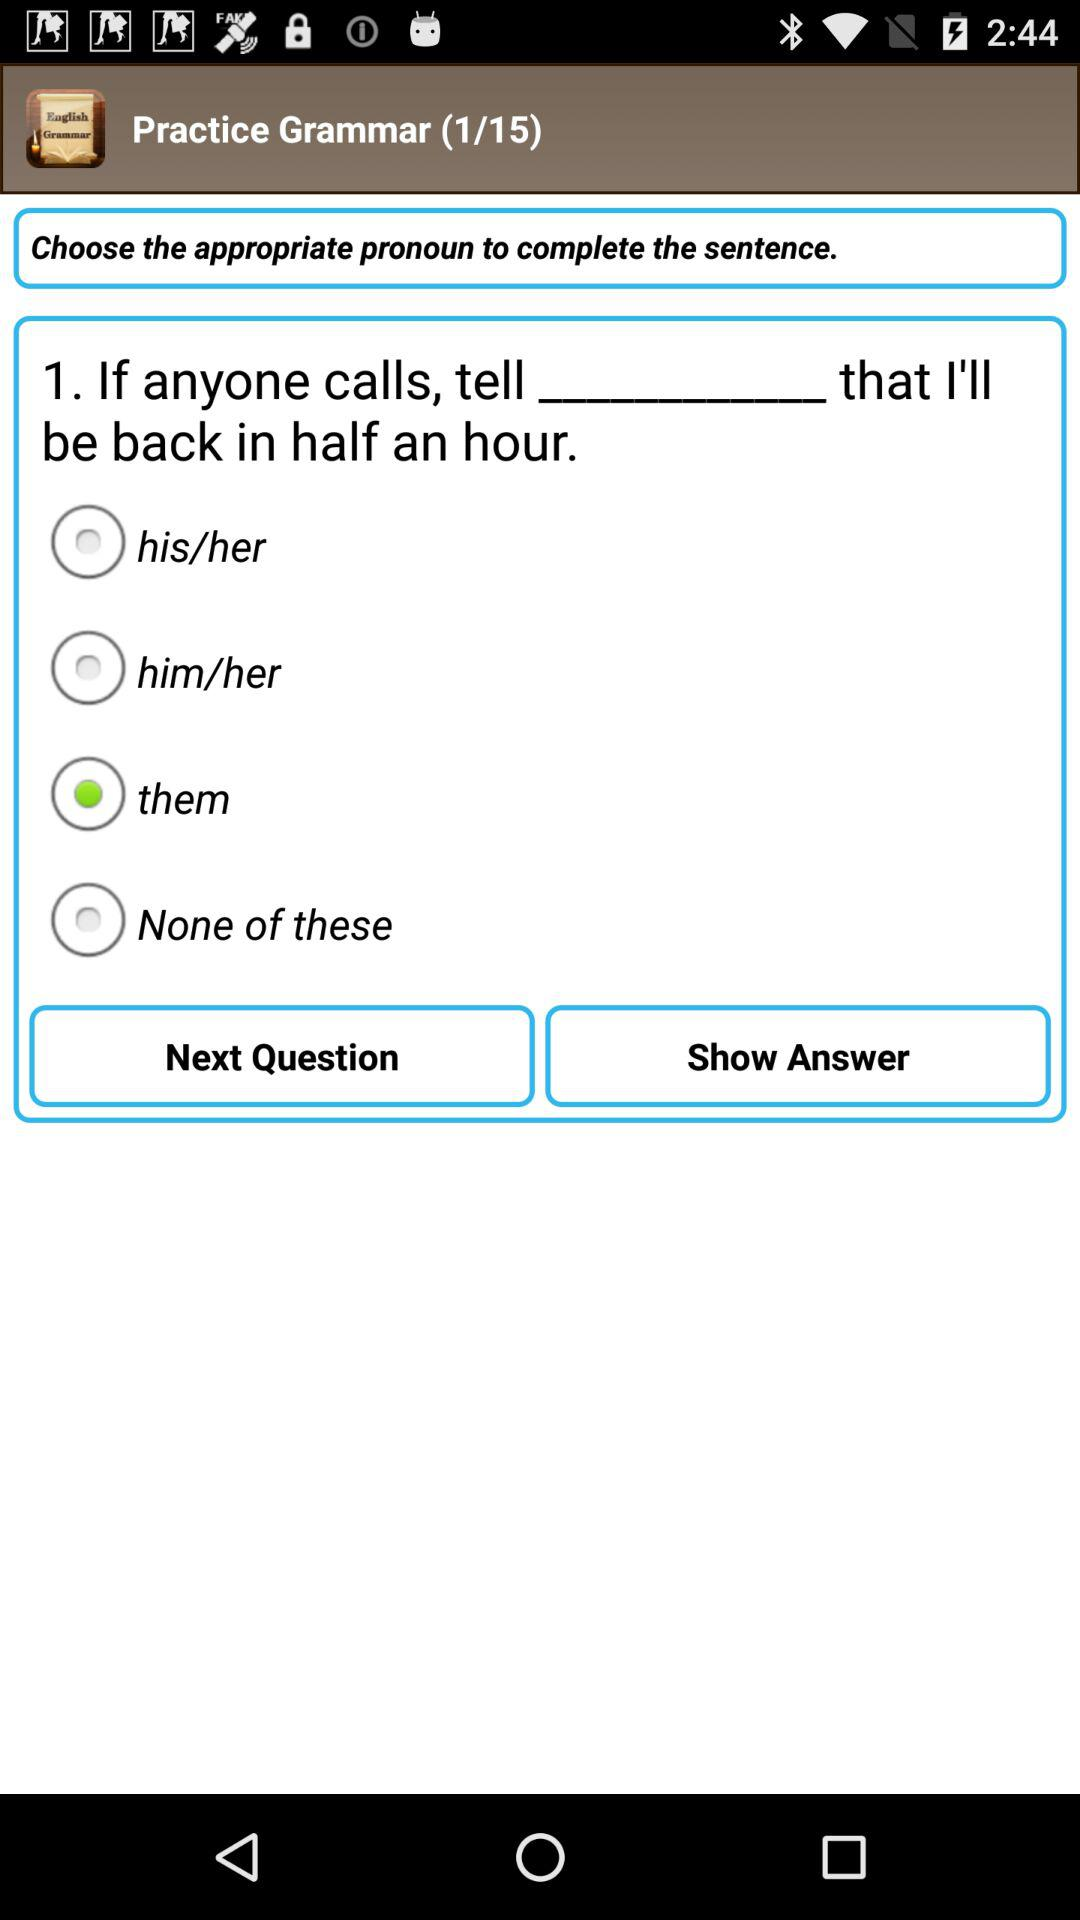What question am I at? You are at question 1. 